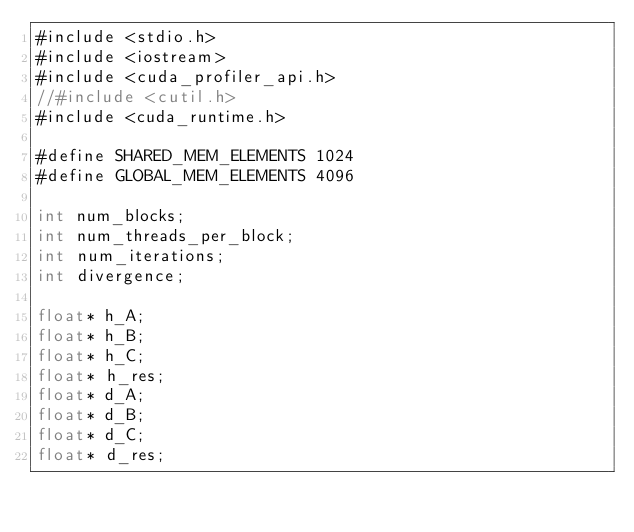<code> <loc_0><loc_0><loc_500><loc_500><_Cuda_>#include <stdio.h>
#include <iostream>
#include <cuda_profiler_api.h>
//#include <cutil.h>
#include <cuda_runtime.h>

#define SHARED_MEM_ELEMENTS 1024
#define GLOBAL_MEM_ELEMENTS 4096

int num_blocks;
int num_threads_per_block;
int num_iterations;
int divergence;

float* h_A;
float* h_B;
float* h_C;
float* h_res;
float* d_A;
float* d_B;
float* d_C;
float* d_res;
</code> 